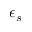Convert formula to latex. <formula><loc_0><loc_0><loc_500><loc_500>\epsilon _ { s }</formula> 